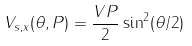<formula> <loc_0><loc_0><loc_500><loc_500>V _ { s , x } ( \theta , P ) = \frac { V P } { 2 } \sin ^ { 2 } ( \theta / 2 )</formula> 